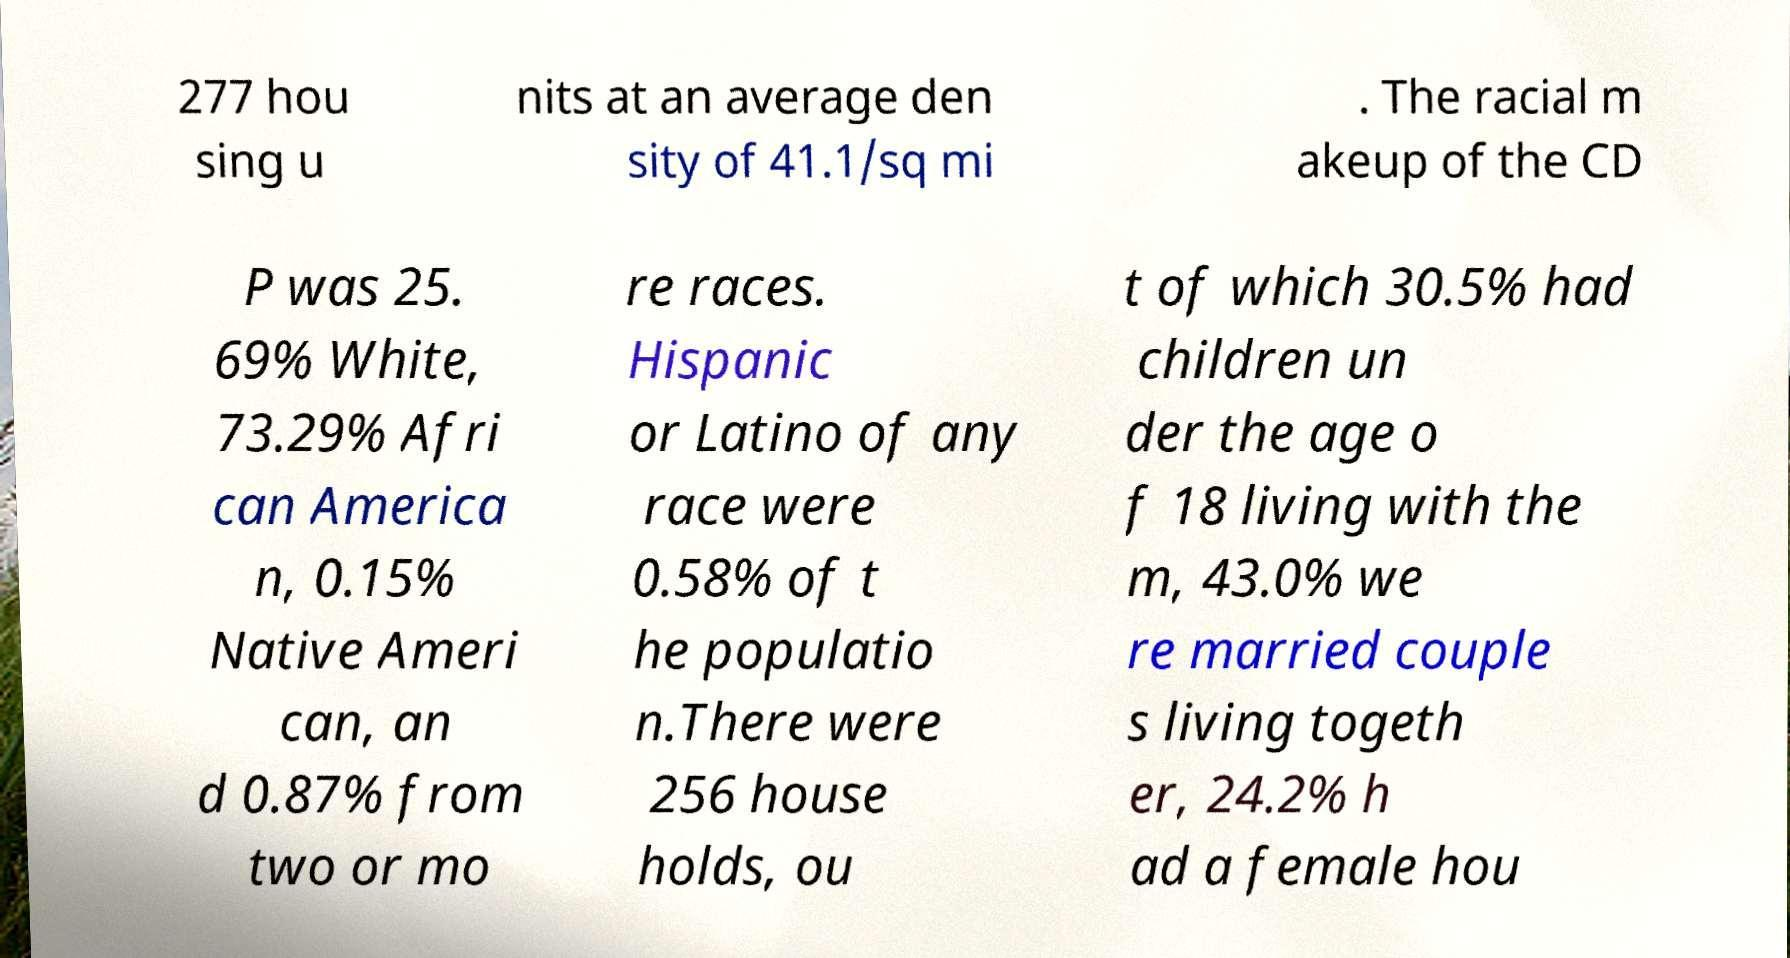Could you extract and type out the text from this image? 277 hou sing u nits at an average den sity of 41.1/sq mi . The racial m akeup of the CD P was 25. 69% White, 73.29% Afri can America n, 0.15% Native Ameri can, an d 0.87% from two or mo re races. Hispanic or Latino of any race were 0.58% of t he populatio n.There were 256 house holds, ou t of which 30.5% had children un der the age o f 18 living with the m, 43.0% we re married couple s living togeth er, 24.2% h ad a female hou 